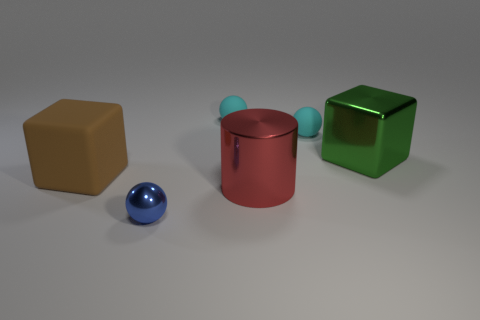There is a cube left of the big metallic thing that is behind the large brown object; how many matte spheres are left of it?
Make the answer very short. 0. What is the color of the metal cylinder that is the same size as the matte block?
Your answer should be very brief. Red. How many other things are the same color as the metal cylinder?
Your response must be concise. 0. Are there more cyan spheres that are in front of the large brown thing than tiny metallic spheres?
Give a very brief answer. No. Is the large red cylinder made of the same material as the small blue sphere?
Offer a very short reply. Yes. What number of objects are either metal balls that are right of the brown matte block or metallic cylinders?
Ensure brevity in your answer.  2. What number of other things are there of the same size as the blue object?
Offer a terse response. 2. Are there the same number of large objects that are in front of the big rubber block and tiny matte spheres that are on the right side of the green shiny cube?
Keep it short and to the point. No. What color is the other thing that is the same shape as the brown thing?
Your response must be concise. Green. Is there anything else that is the same shape as the small blue thing?
Offer a very short reply. Yes. 